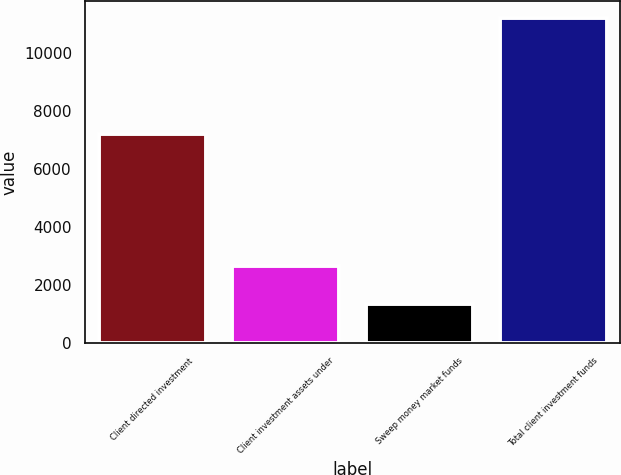Convert chart. <chart><loc_0><loc_0><loc_500><loc_500><bar_chart><fcel>Client directed investment<fcel>Client investment assets under<fcel>Sweep money market funds<fcel>Total client investment funds<nl><fcel>7208<fcel>2678<fcel>1351<fcel>11237<nl></chart> 